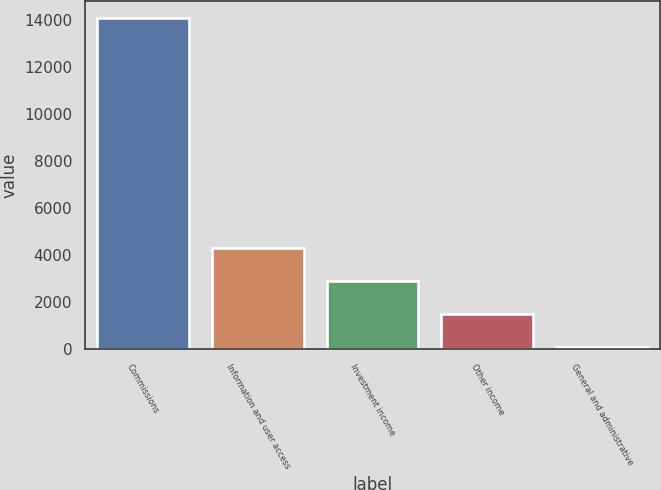Convert chart to OTSL. <chart><loc_0><loc_0><loc_500><loc_500><bar_chart><fcel>Commissions<fcel>Information and user access<fcel>Investment income<fcel>Other income<fcel>General and administrative<nl><fcel>14103<fcel>4286.2<fcel>2883.8<fcel>1481.4<fcel>79<nl></chart> 